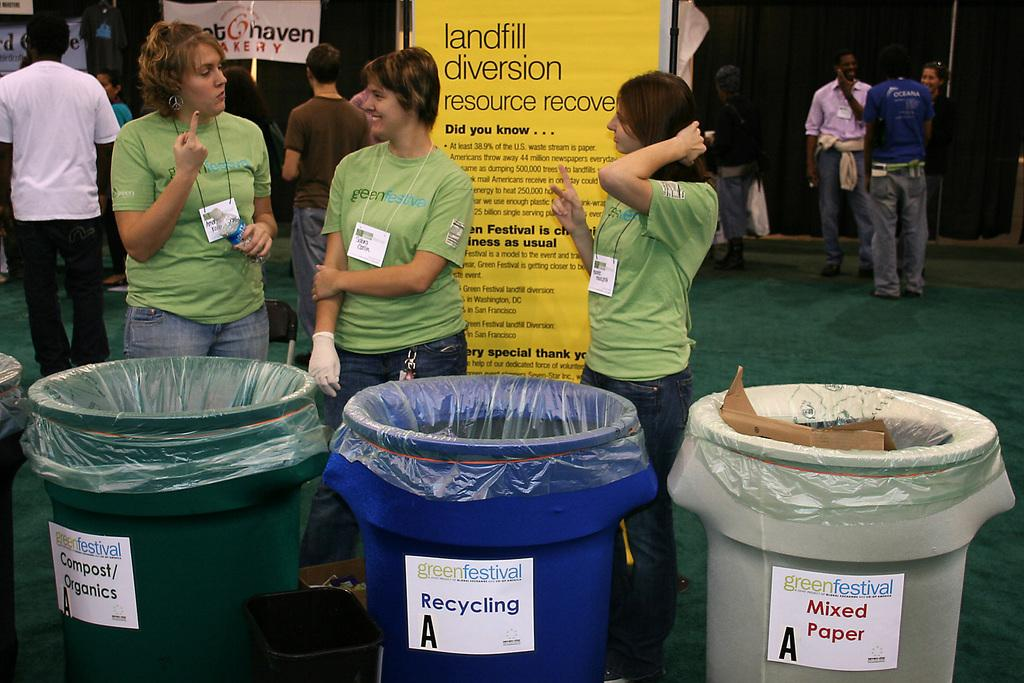<image>
Render a clear and concise summary of the photo. Three trash cans are lined up together and one is flagged for mixed paper. 